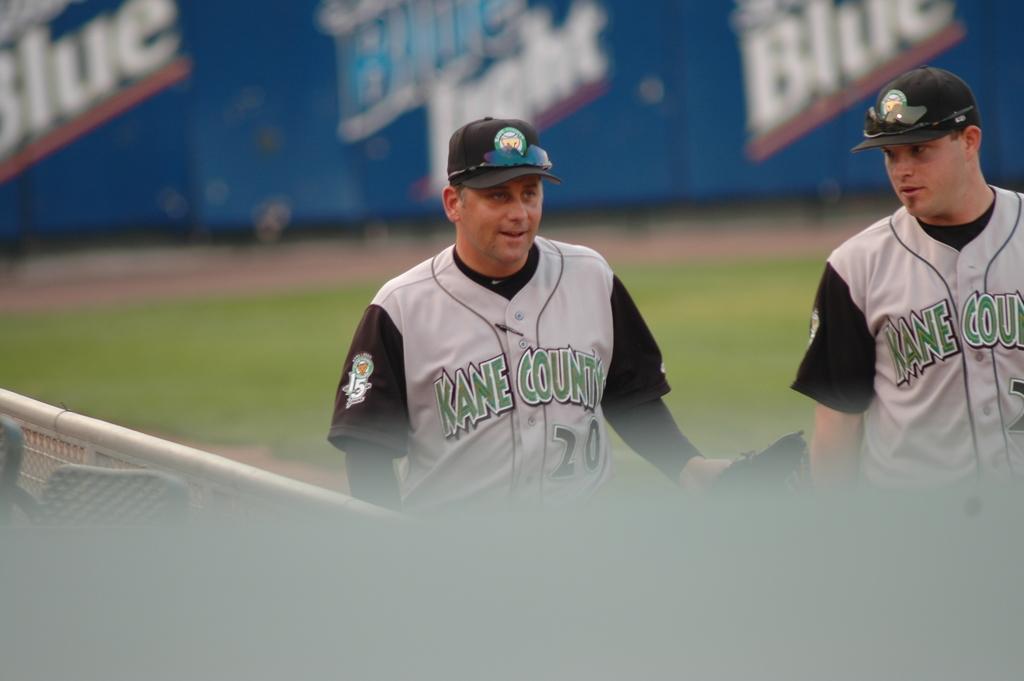What is the number of the player?
Give a very brief answer. 20. 